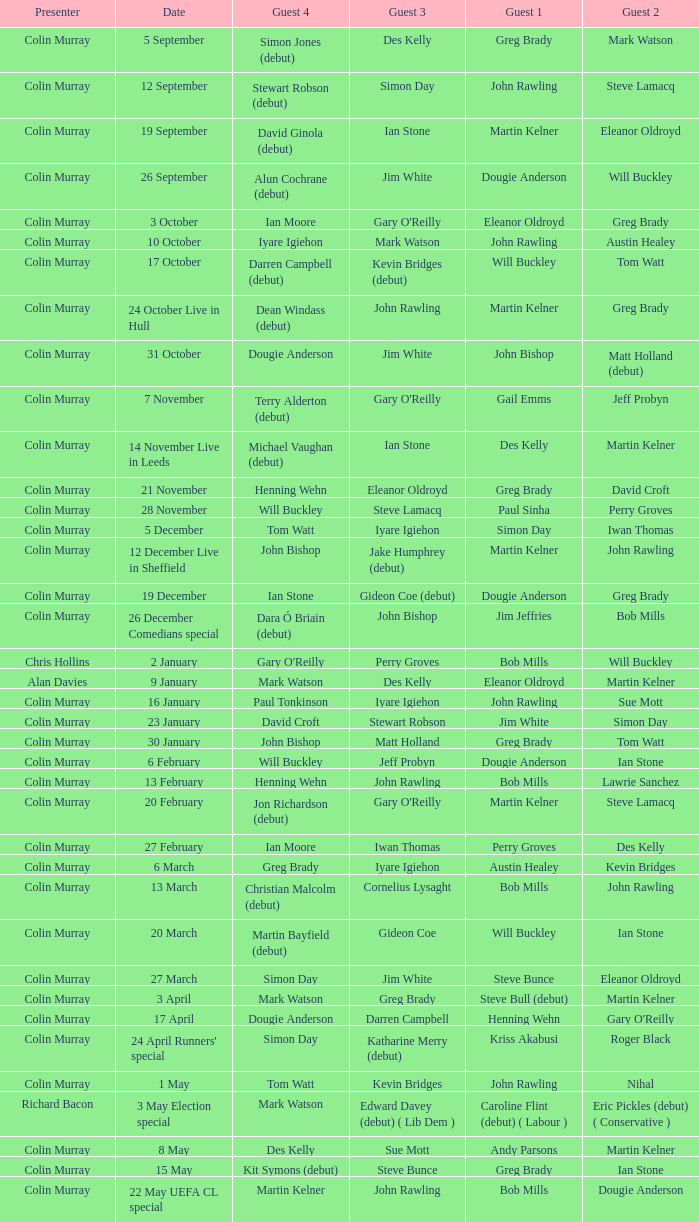How many people are guest 1 on episodes where guest 4 is Des Kelly? 1.0. 